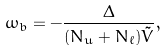<formula> <loc_0><loc_0><loc_500><loc_500>\omega _ { b } = - \frac { \Delta } { ( N _ { u } + N _ { \ell } ) \tilde { V } } ,</formula> 